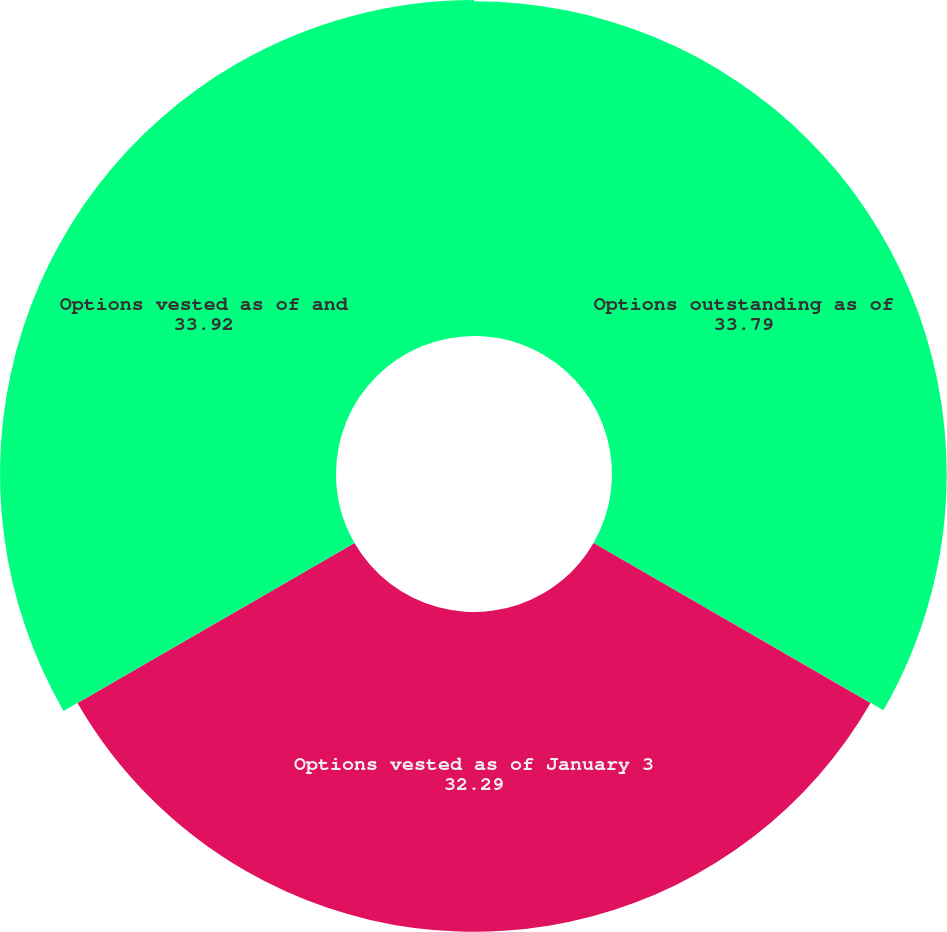Convert chart. <chart><loc_0><loc_0><loc_500><loc_500><pie_chart><fcel>Options outstanding as of<fcel>Options vested as of January 3<fcel>Options vested as of and<nl><fcel>33.79%<fcel>32.29%<fcel>33.92%<nl></chart> 